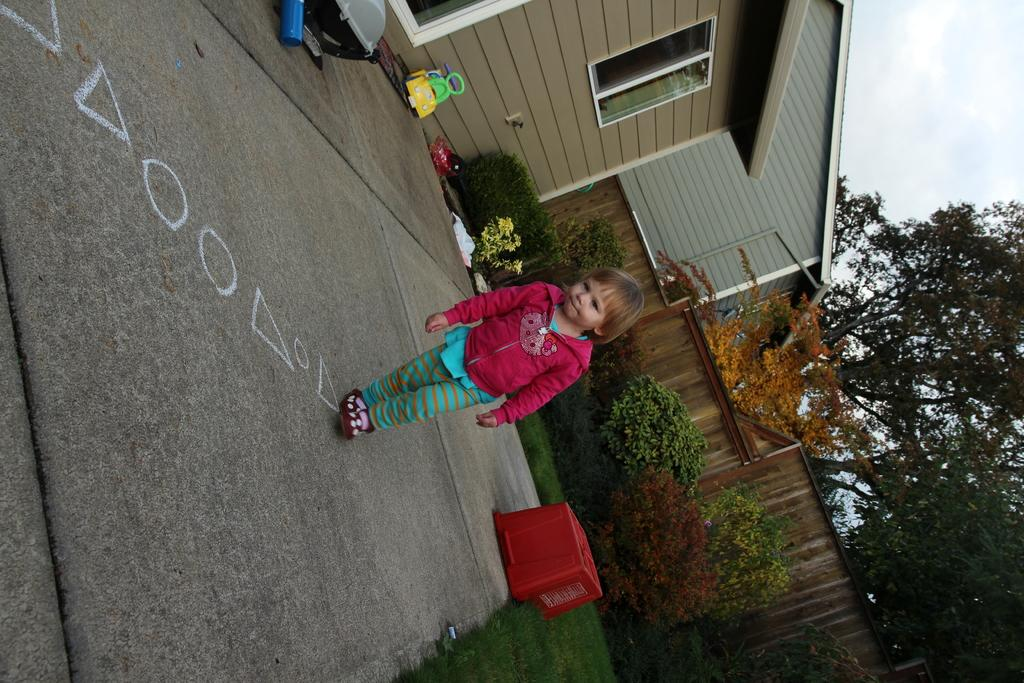What is the main subject of the image? The main subject of the image is a girl walking. On what surface is the girl walking? The girl is walking on the floor. What other objects or elements can be seen in the image? There are toys, bushes, plants, shrubs, buildings, trees, and the sky visible in the image. What is the condition of the sky in the image? The sky is visible in the image, and there are clouds present. What type of snow can be seen falling in the image? There is no snow present in the image; it features a girl walking on the floor with various objects and elements visible in the background. Can you describe the tail of the animal in the image? There is no animal with a tail present in the image; it features a girl walking and various objects and elements in the background. 